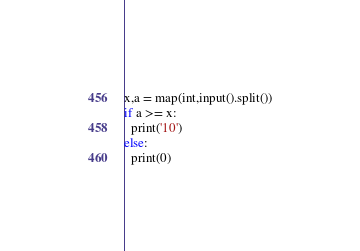Convert code to text. <code><loc_0><loc_0><loc_500><loc_500><_Python_>x,a = map(int,input().split())
if a >= x:
  print('10')
else:
  print(0)</code> 